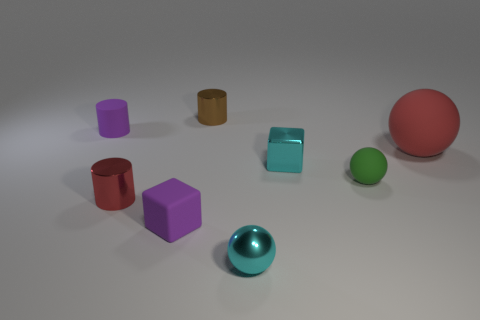Subtract all tiny metallic spheres. How many spheres are left? 2 Add 2 purple metal objects. How many objects exist? 10 Subtract all blocks. How many objects are left? 6 Subtract 1 cylinders. How many cylinders are left? 2 Add 7 yellow rubber things. How many yellow rubber things exist? 7 Subtract 0 green cubes. How many objects are left? 8 Subtract all green cylinders. Subtract all yellow blocks. How many cylinders are left? 3 Subtract all cyan metal balls. Subtract all matte cylinders. How many objects are left? 6 Add 7 small rubber things. How many small rubber things are left? 10 